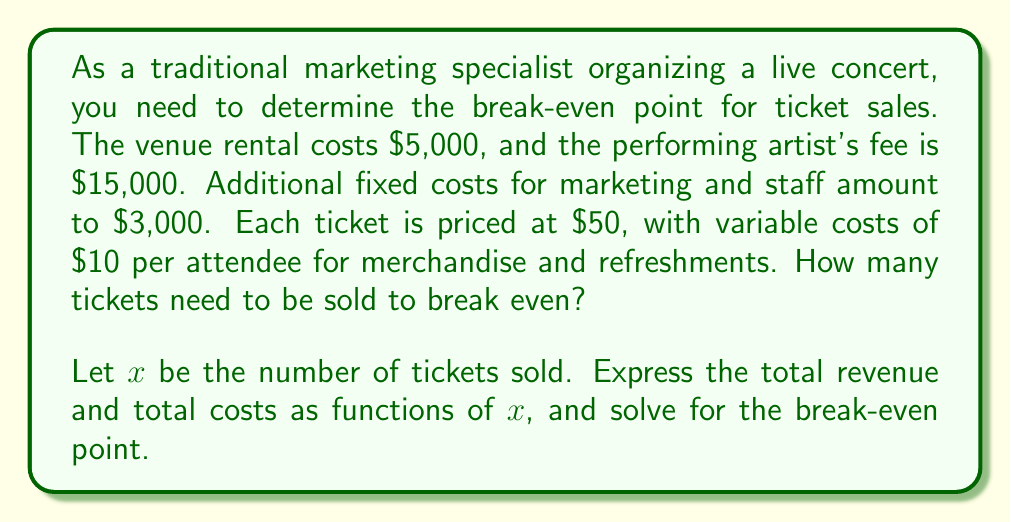Give your solution to this math problem. To solve this problem, we need to follow these steps:

1. Express the total revenue as a function of $x$:
   Revenue = Ticket price × Number of tickets sold
   $R(x) = 50x$

2. Express the total costs as a function of $x$:
   Total Costs = Fixed Costs + Variable Costs
   $C(x) = (5000 + 15000 + 3000) + 10x$
   $C(x) = 23000 + 10x$

3. At the break-even point, total revenue equals total costs:
   $R(x) = C(x)$
   $50x = 23000 + 10x$

4. Solve the equation for $x$:
   $50x - 10x = 23000$
   $40x = 23000$
   $x = \frac{23000}{40} = 575$

Therefore, the break-even point occurs when 575 tickets are sold.

To verify:
Revenue at 575 tickets: $R(575) = 50 \times 575 = 28750$
Costs at 575 tickets: $C(575) = 23000 + 10 \times 575 = 28750$

The revenue and costs are equal at 575 tickets, confirming the break-even point.
Answer: The break-even point is 575 tickets. 